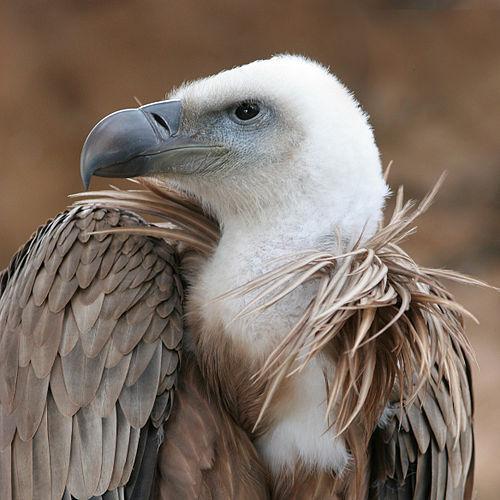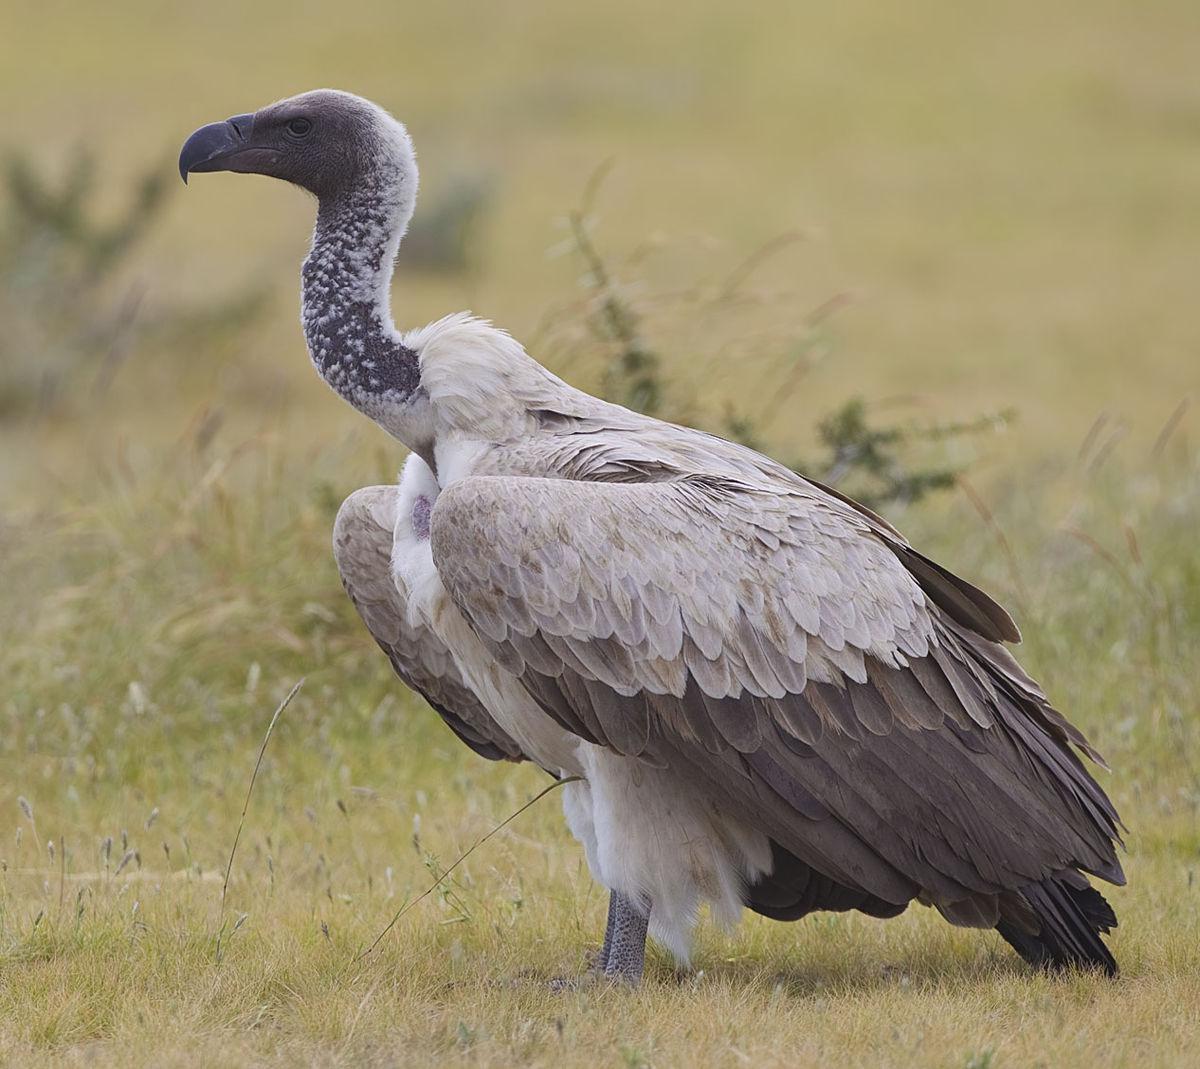The first image is the image on the left, the second image is the image on the right. Evaluate the accuracy of this statement regarding the images: "There is exactly one bird with its wings folded in the image on the right". Is it true? Answer yes or no. Yes. The first image is the image on the left, the second image is the image on the right. Analyze the images presented: Is the assertion "Some of the birds are eating something that is on the ground." valid? Answer yes or no. No. 